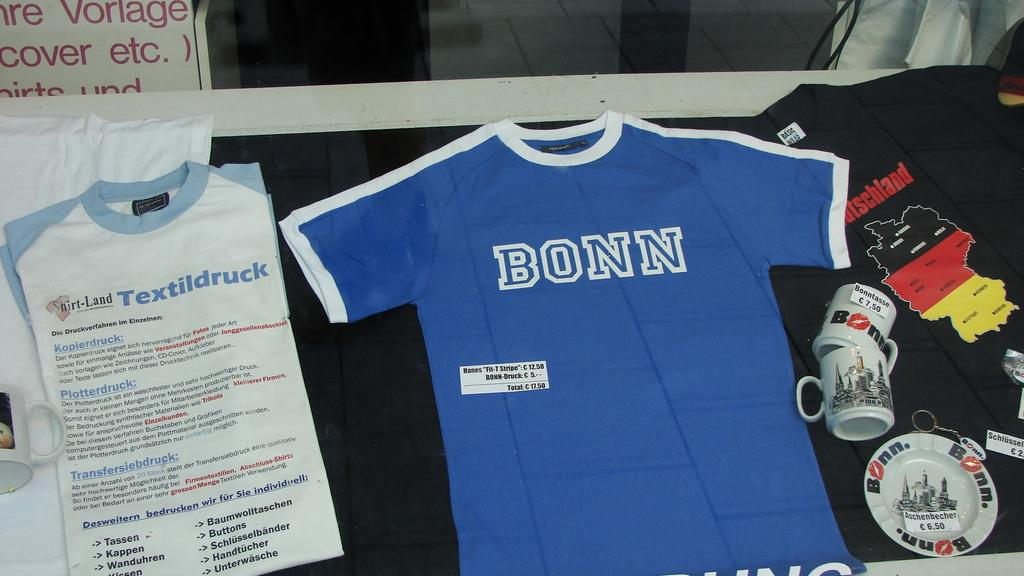<image>
Give a short and clear explanation of the subsequent image. A shirt company called Shirt-Land has a display set up with shirts, mugs, and information. 